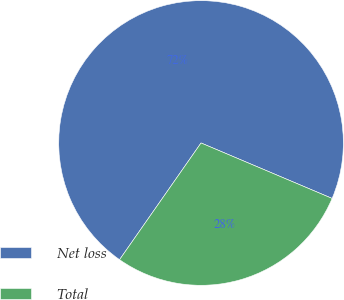Convert chart. <chart><loc_0><loc_0><loc_500><loc_500><pie_chart><fcel>Net loss<fcel>Total<nl><fcel>71.67%<fcel>28.33%<nl></chart> 